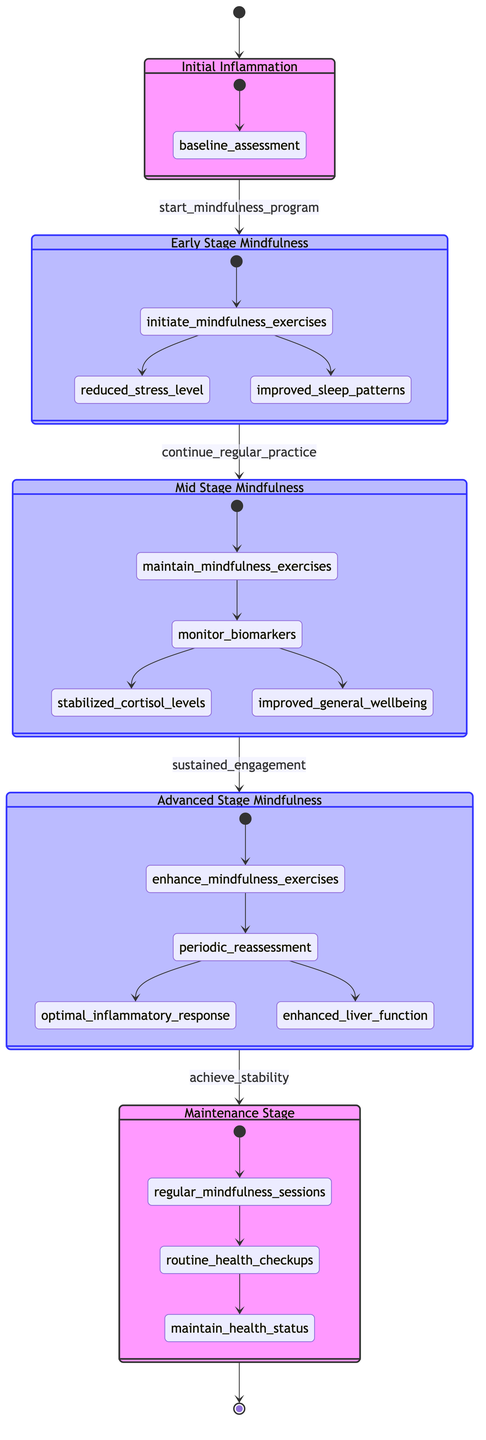What is the starting state of the diagram? The starting state of the diagram is labeled as "Initial Inflammation," which is the first node connected by an arrow.
Answer: Initial Inflammation How many main states are there in the diagram? By counting the nodes labeled as states, there are five main states: Initial Inflammation, Early Stage Mindfulness, Mid Stage Mindfulness, Advanced Stage Mindfulness, and Maintenance Stage.
Answer: 5 What is the transition trigger from Early Stage Mindfulness to Mid Stage Mindfulness? The transition from Early Stage Mindfulness to Mid Stage Mindfulness is triggered by "continue_regular_practice," which is indicated on the connecting arrow.
Answer: continue_regular_practice What actions are associated with the Advanced Stage Mindfulness? The actions associated with the Advanced Stage Mindfulness are "enhance_mindfulness_exercises" and "periodic_reassessment," which are listed within the state block.
Answer: enhance_mindfulness_exercises, periodic_reassessment What is the final state reached in the mindfulness practice? The final state of the mindfulness practice, as represented in the diagram, is "Maintenance Stage," which is the last node in the sequence before cycling back to the starting point.
Answer: Maintenance Stage What are the transitions identified in the diagram? The transitions identified in the diagram include: start mindfulness program, continue regular practice, sustained engagement, and achieve stability; these are the triggers for moving between states.
Answer: start mindfulness program, continue regular practice, sustained engagement, achieve stability Which state describes the introduction of mindfulness practices? The state that describes the introduction of mindfulness practices is "Early Stage Mindfulness," where practices like meditation and deep breathing exercises begin.
Answer: Early Stage Mindfulness What is the result of "sustained_engagement" in the diagram? The result of "sustained_engagement" in the diagram leads to the transition from Mid Stage Mindfulness to Advanced Stage Mindfulness, indicating a progression due to ongoing mindfulness practices.
Answer: Advanced Stage Mindfulness 